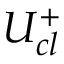<formula> <loc_0><loc_0><loc_500><loc_500>U _ { c l } ^ { + }</formula> 